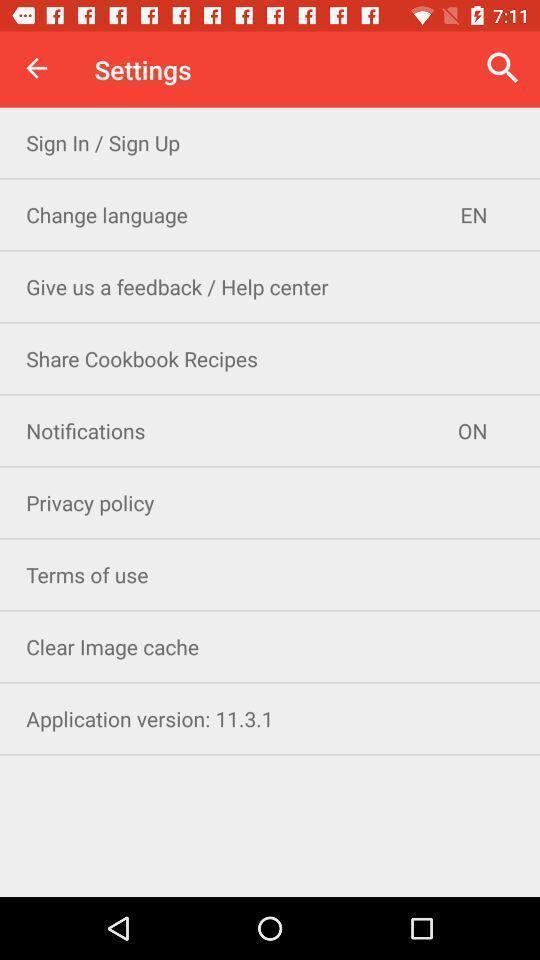Summarize the information in this screenshot. Settings tab in the application with different options. 